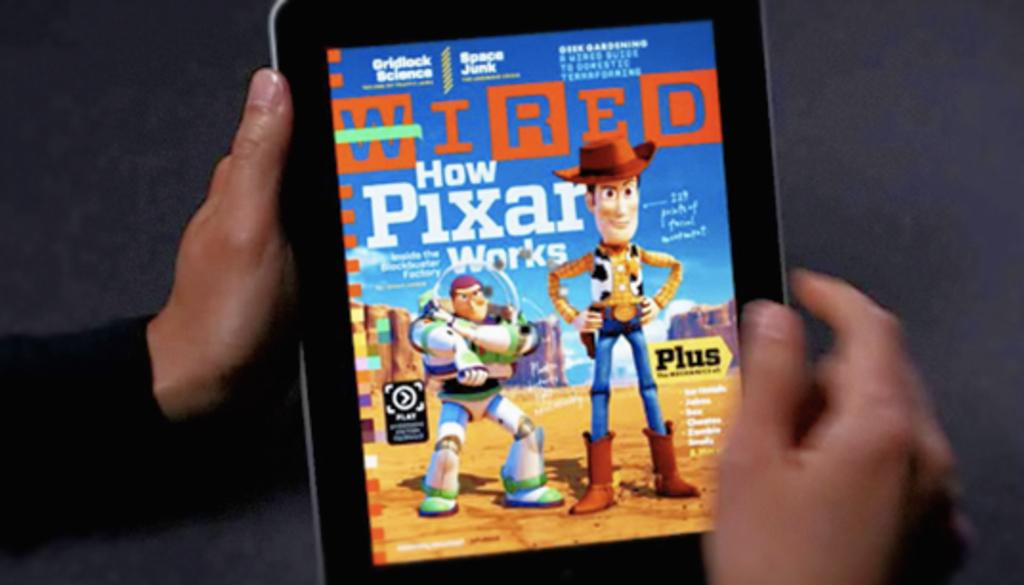<image>
Render a clear and concise summary of the photo. hands holding a tablet displaying Wired, how pixar works and woody and buzz lightyear standing looking forward 